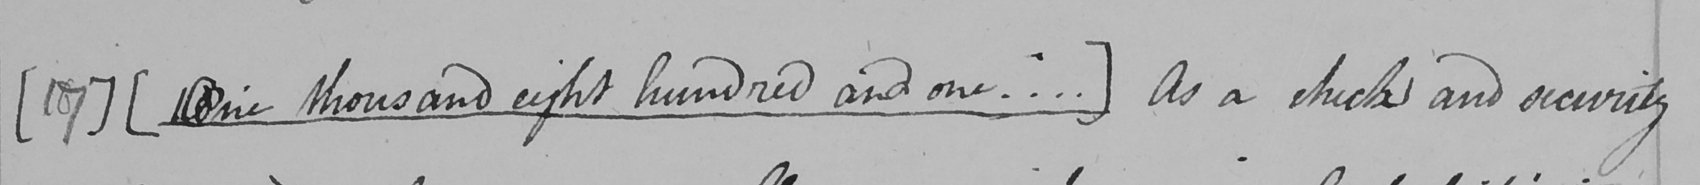What is written in this line of handwriting? [ 17 ]   [ One thousand eight hundred and one ... . ]  As a check and security 